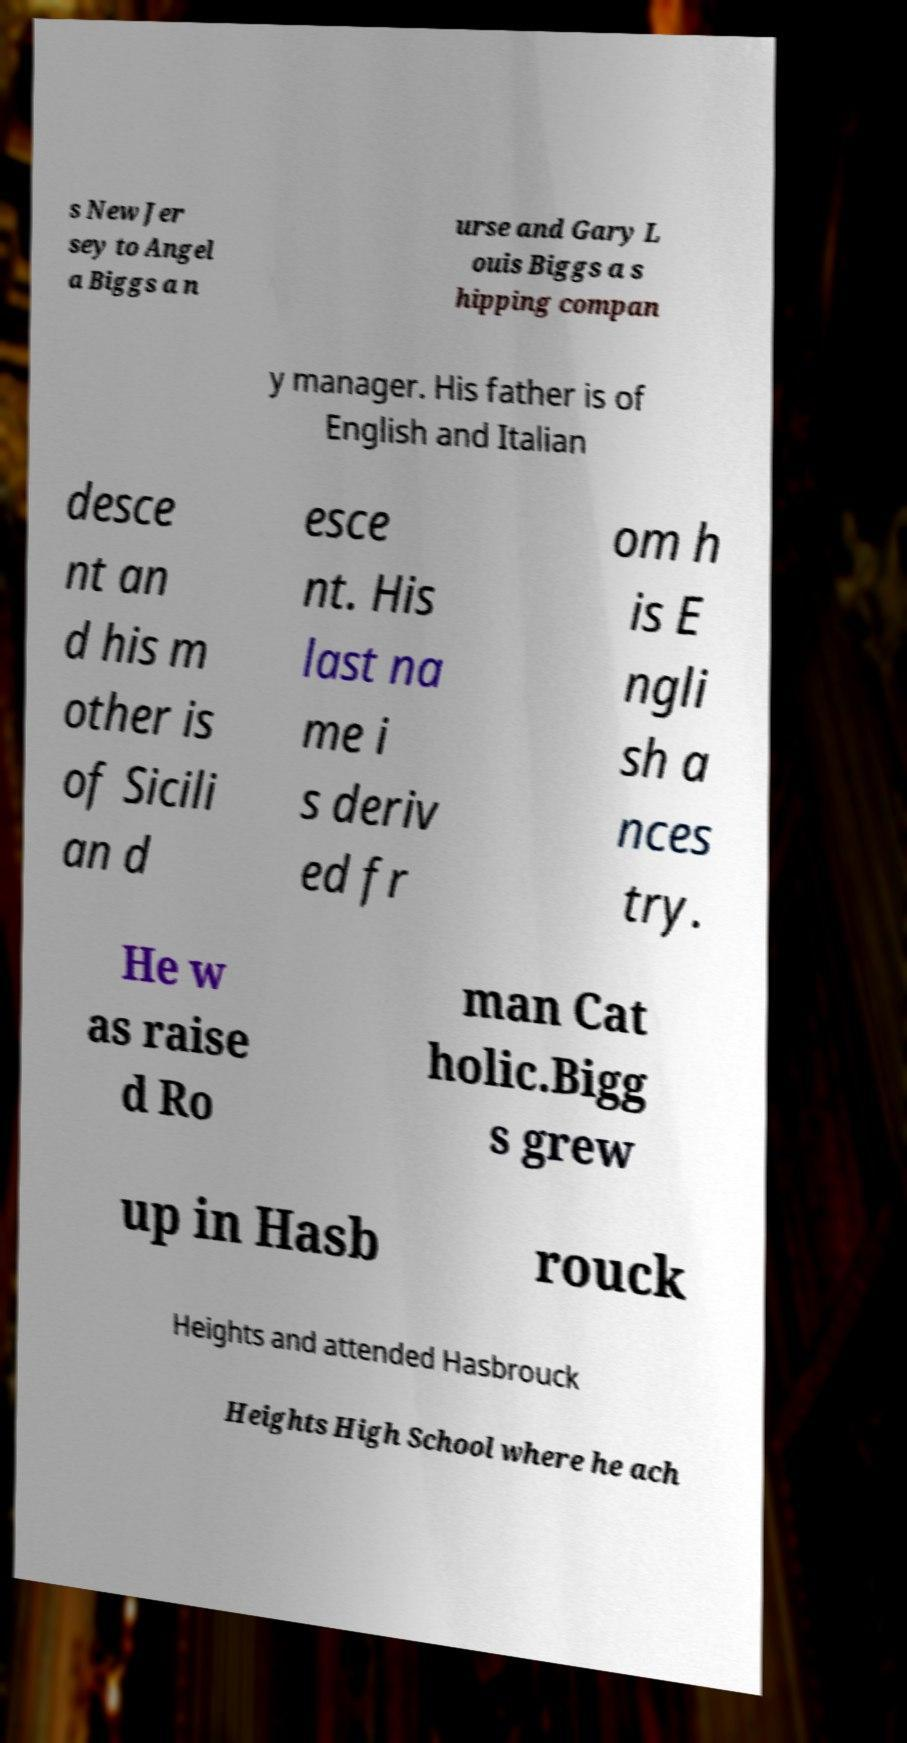Can you accurately transcribe the text from the provided image for me? s New Jer sey to Angel a Biggs a n urse and Gary L ouis Biggs a s hipping compan y manager. His father is of English and Italian desce nt an d his m other is of Sicili an d esce nt. His last na me i s deriv ed fr om h is E ngli sh a nces try. He w as raise d Ro man Cat holic.Bigg s grew up in Hasb rouck Heights and attended Hasbrouck Heights High School where he ach 